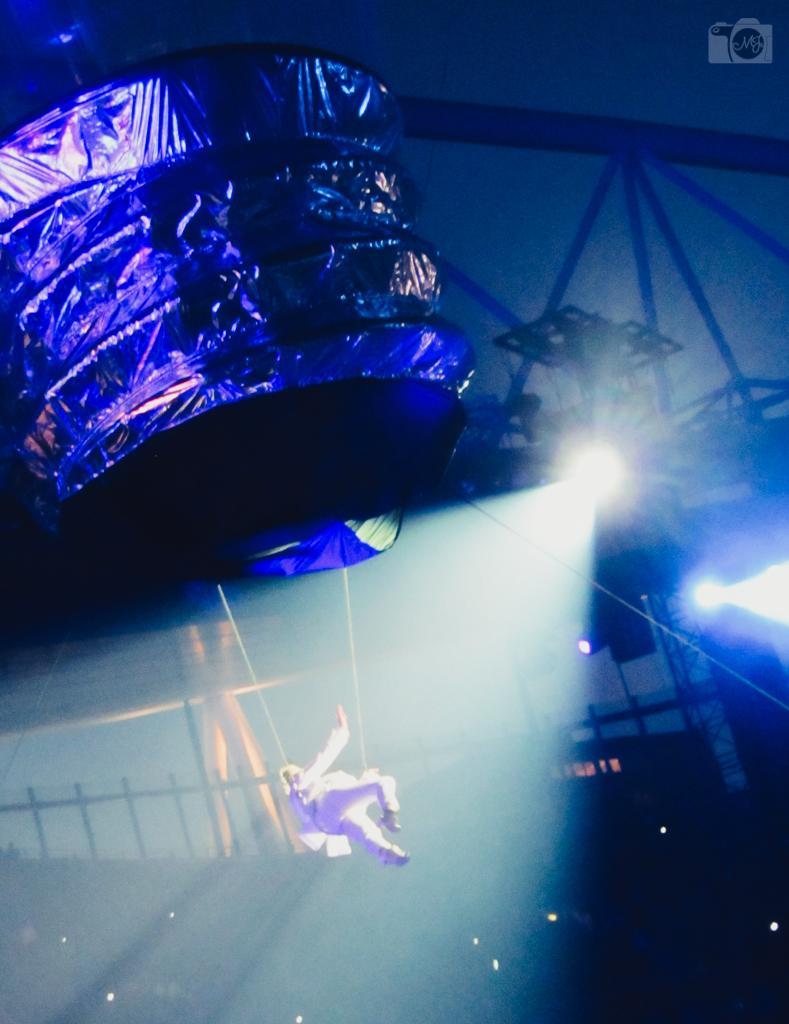Can you describe this image briefly? In this image there is a person hanging from the ropes. At the top of the image there is some object connected through metal rods. There is a metal fence. There are lights. 